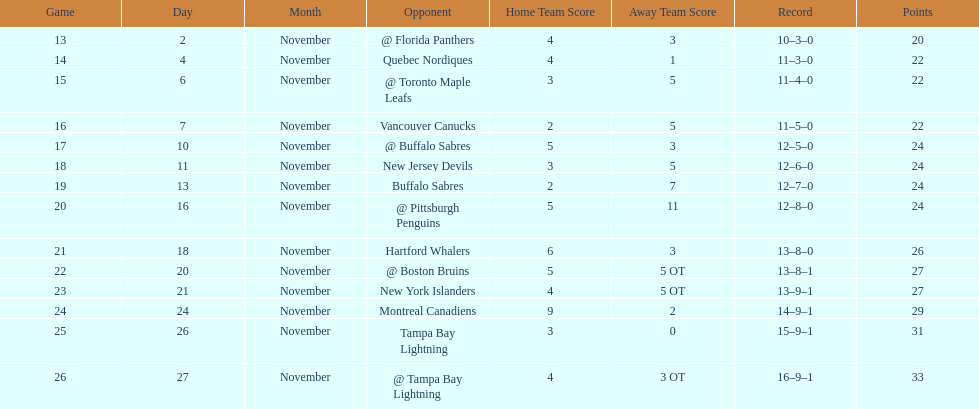Who had the most assists on the 1993-1994 flyers? Mark Recchi. 